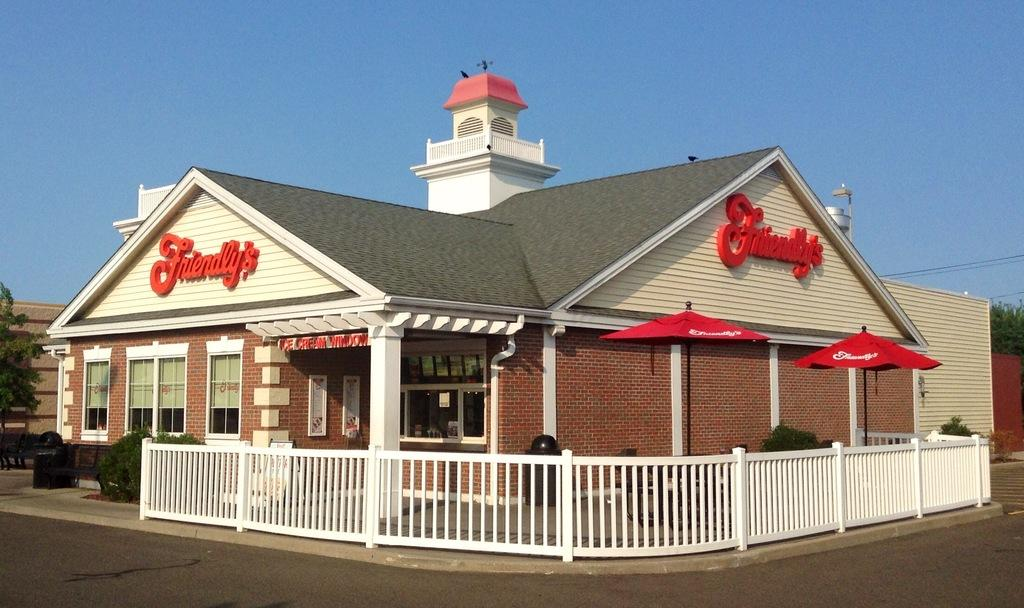<image>
Write a terse but informative summary of the picture. The Friendly's restaurant has a white fence around the outdoor seating area. 